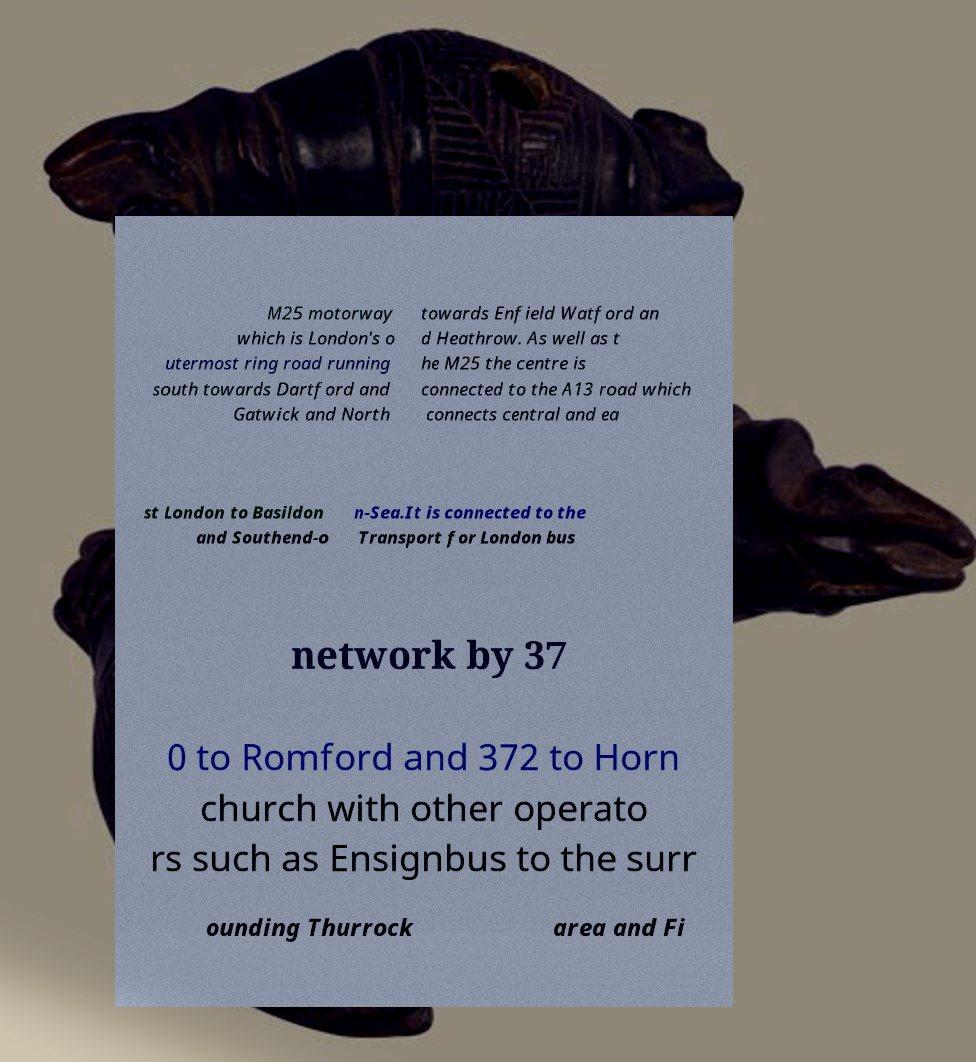Can you read and provide the text displayed in the image?This photo seems to have some interesting text. Can you extract and type it out for me? M25 motorway which is London's o utermost ring road running south towards Dartford and Gatwick and North towards Enfield Watford an d Heathrow. As well as t he M25 the centre is connected to the A13 road which connects central and ea st London to Basildon and Southend-o n-Sea.It is connected to the Transport for London bus network by 37 0 to Romford and 372 to Horn church with other operato rs such as Ensignbus to the surr ounding Thurrock area and Fi 